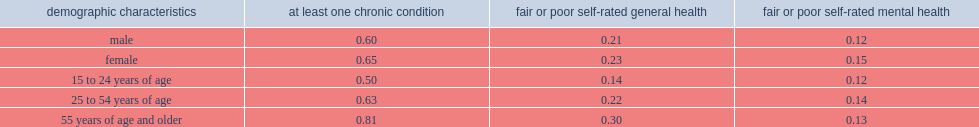Among off-reserve first nations people, what was the proportion of male that had at least one chronic condition? 0.6. Among off-reserve first nations people, what was the proportion of female that had at least one chronic condition? 0.65. Among off-reserve first nations people, which gender was more likely to report having at least one chronic condition? Female. 